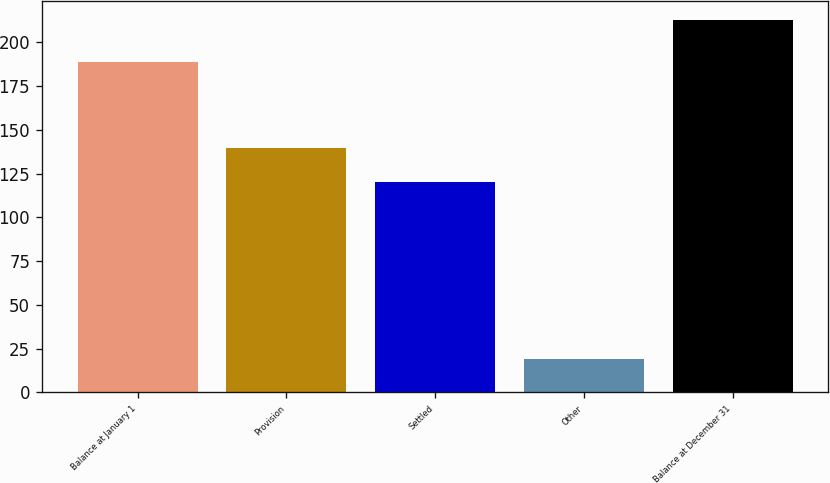Convert chart to OTSL. <chart><loc_0><loc_0><loc_500><loc_500><bar_chart><fcel>Balance at January 1<fcel>Provision<fcel>Settled<fcel>Other<fcel>Balance at December 31<nl><fcel>189<fcel>139.4<fcel>120<fcel>19<fcel>213<nl></chart> 